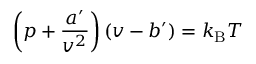<formula> <loc_0><loc_0><loc_500><loc_500>\left ( p + { \frac { a ^ { \prime } } { v ^ { 2 } } } \right ) \left ( v - b ^ { \prime } \right ) = k _ { B } T</formula> 